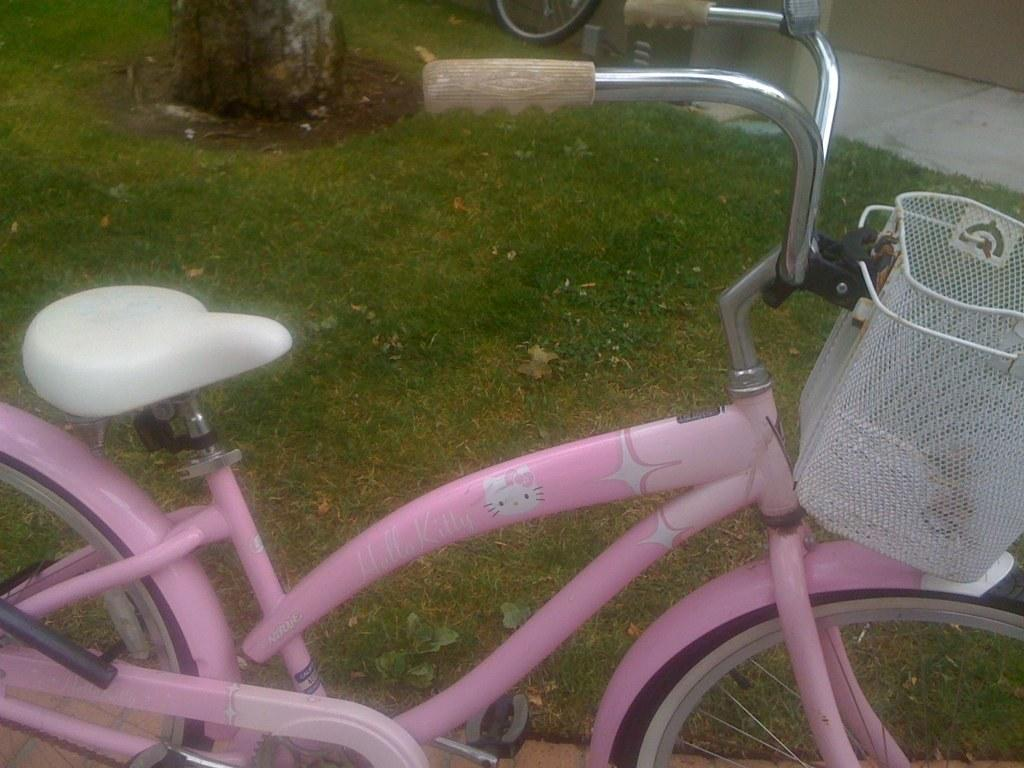What is the main subject of the image? The main subject of the image is a bicycle. What color is the bicycle? The bicycle is colored pink. What type of writing can be seen on the bicycle in the image? There is no writing visible on the bicycle in the image. 